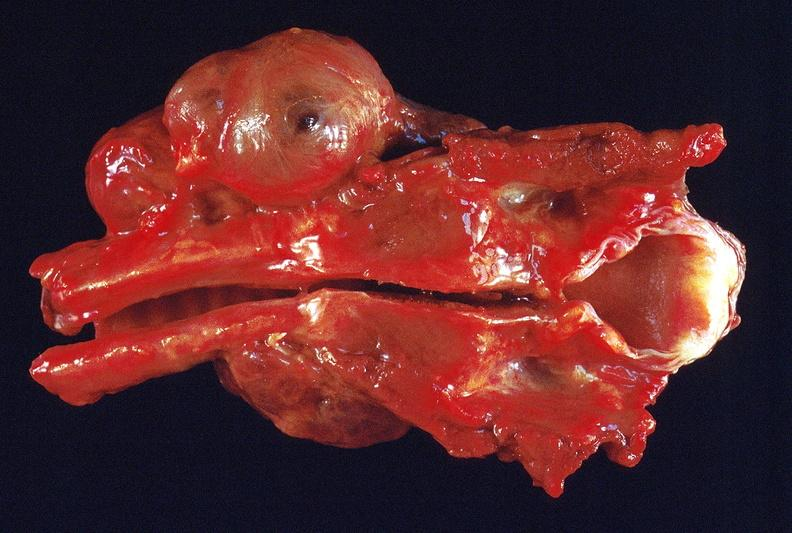does this image show thyroid, goiter?
Answer the question using a single word or phrase. Yes 